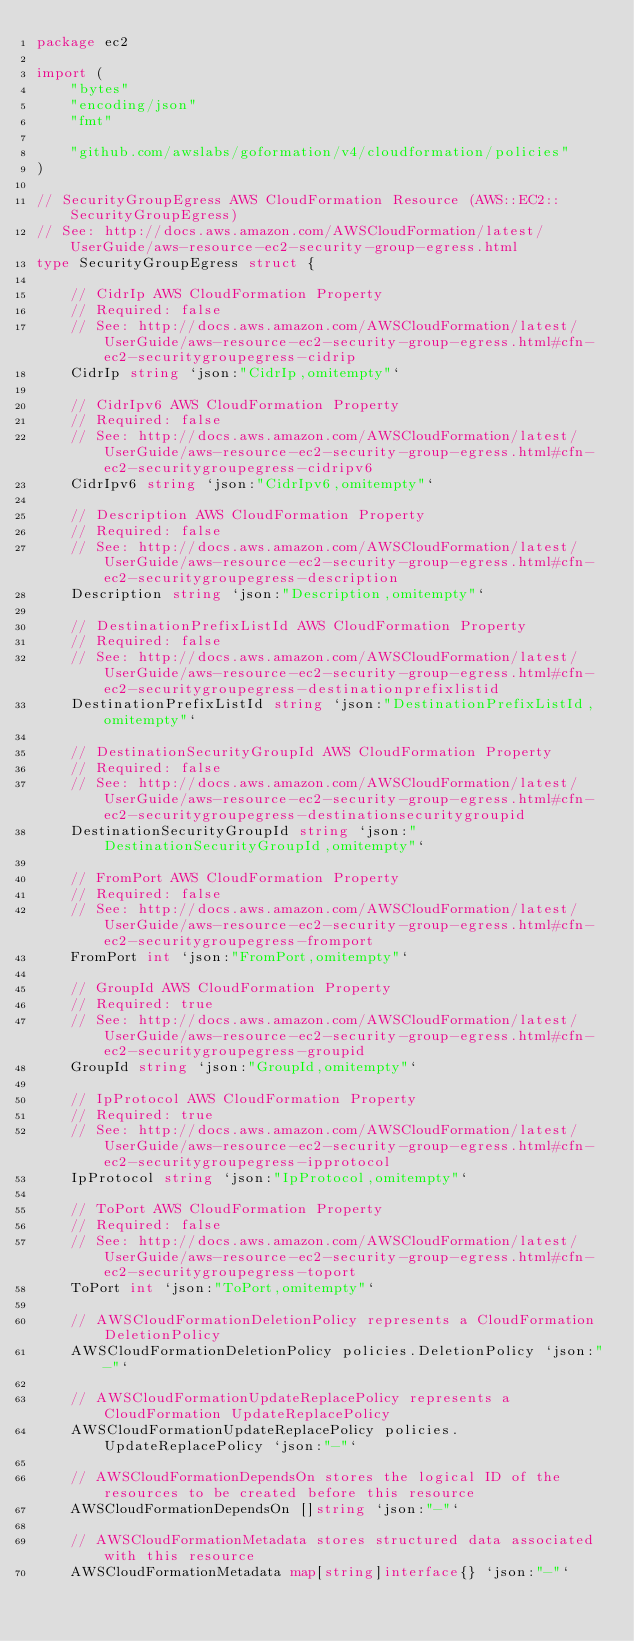Convert code to text. <code><loc_0><loc_0><loc_500><loc_500><_Go_>package ec2

import (
	"bytes"
	"encoding/json"
	"fmt"

	"github.com/awslabs/goformation/v4/cloudformation/policies"
)

// SecurityGroupEgress AWS CloudFormation Resource (AWS::EC2::SecurityGroupEgress)
// See: http://docs.aws.amazon.com/AWSCloudFormation/latest/UserGuide/aws-resource-ec2-security-group-egress.html
type SecurityGroupEgress struct {

	// CidrIp AWS CloudFormation Property
	// Required: false
	// See: http://docs.aws.amazon.com/AWSCloudFormation/latest/UserGuide/aws-resource-ec2-security-group-egress.html#cfn-ec2-securitygroupegress-cidrip
	CidrIp string `json:"CidrIp,omitempty"`

	// CidrIpv6 AWS CloudFormation Property
	// Required: false
	// See: http://docs.aws.amazon.com/AWSCloudFormation/latest/UserGuide/aws-resource-ec2-security-group-egress.html#cfn-ec2-securitygroupegress-cidripv6
	CidrIpv6 string `json:"CidrIpv6,omitempty"`

	// Description AWS CloudFormation Property
	// Required: false
	// See: http://docs.aws.amazon.com/AWSCloudFormation/latest/UserGuide/aws-resource-ec2-security-group-egress.html#cfn-ec2-securitygroupegress-description
	Description string `json:"Description,omitempty"`

	// DestinationPrefixListId AWS CloudFormation Property
	// Required: false
	// See: http://docs.aws.amazon.com/AWSCloudFormation/latest/UserGuide/aws-resource-ec2-security-group-egress.html#cfn-ec2-securitygroupegress-destinationprefixlistid
	DestinationPrefixListId string `json:"DestinationPrefixListId,omitempty"`

	// DestinationSecurityGroupId AWS CloudFormation Property
	// Required: false
	// See: http://docs.aws.amazon.com/AWSCloudFormation/latest/UserGuide/aws-resource-ec2-security-group-egress.html#cfn-ec2-securitygroupegress-destinationsecuritygroupid
	DestinationSecurityGroupId string `json:"DestinationSecurityGroupId,omitempty"`

	// FromPort AWS CloudFormation Property
	// Required: false
	// See: http://docs.aws.amazon.com/AWSCloudFormation/latest/UserGuide/aws-resource-ec2-security-group-egress.html#cfn-ec2-securitygroupegress-fromport
	FromPort int `json:"FromPort,omitempty"`

	// GroupId AWS CloudFormation Property
	// Required: true
	// See: http://docs.aws.amazon.com/AWSCloudFormation/latest/UserGuide/aws-resource-ec2-security-group-egress.html#cfn-ec2-securitygroupegress-groupid
	GroupId string `json:"GroupId,omitempty"`

	// IpProtocol AWS CloudFormation Property
	// Required: true
	// See: http://docs.aws.amazon.com/AWSCloudFormation/latest/UserGuide/aws-resource-ec2-security-group-egress.html#cfn-ec2-securitygroupegress-ipprotocol
	IpProtocol string `json:"IpProtocol,omitempty"`

	// ToPort AWS CloudFormation Property
	// Required: false
	// See: http://docs.aws.amazon.com/AWSCloudFormation/latest/UserGuide/aws-resource-ec2-security-group-egress.html#cfn-ec2-securitygroupegress-toport
	ToPort int `json:"ToPort,omitempty"`

	// AWSCloudFormationDeletionPolicy represents a CloudFormation DeletionPolicy
	AWSCloudFormationDeletionPolicy policies.DeletionPolicy `json:"-"`

	// AWSCloudFormationUpdateReplacePolicy represents a CloudFormation UpdateReplacePolicy
	AWSCloudFormationUpdateReplacePolicy policies.UpdateReplacePolicy `json:"-"`

	// AWSCloudFormationDependsOn stores the logical ID of the resources to be created before this resource
	AWSCloudFormationDependsOn []string `json:"-"`

	// AWSCloudFormationMetadata stores structured data associated with this resource
	AWSCloudFormationMetadata map[string]interface{} `json:"-"`
</code> 